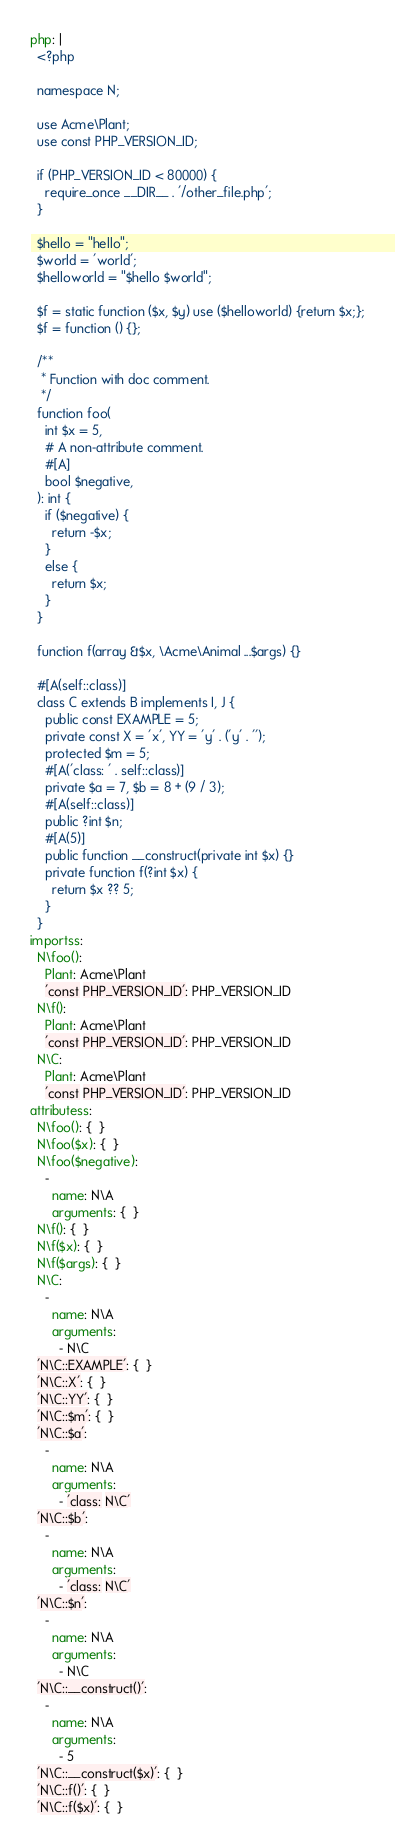Convert code to text. <code><loc_0><loc_0><loc_500><loc_500><_YAML_>php: |
  <?php

  namespace N;

  use Acme\Plant;
  use const PHP_VERSION_ID;

  if (PHP_VERSION_ID < 80000) {
    require_once __DIR__ . '/other_file.php';
  }

  $hello = "hello";
  $world = 'world';
  $helloworld = "$hello $world";

  $f = static function ($x, $y) use ($helloworld) {return $x;};
  $f = function () {};

  /**
   * Function with doc comment.
   */
  function foo(
    int $x = 5,
    # A non-attribute comment.
    #[A]
    bool $negative,
  ): int {
    if ($negative) {
      return -$x;
    }
    else {
      return $x;
    }
  }

  function f(array &$x, \Acme\Animal ...$args) {}

  #[A(self::class)]
  class C extends B implements I, J {
    public const EXAMPLE = 5;
    private const X = 'x', YY = 'y' . ('y' . '');
    protected $m = 5;
    #[A('class: ' . self::class)]
    private $a = 7, $b = 8 + (9 / 3);
    #[A(self::class)]
    public ?int $n;
    #[A(5)]
    public function __construct(private int $x) {}
    private function f(?int $x) {
      return $x ?? 5;
    }
  }
importss:
  N\foo():
    Plant: Acme\Plant
    'const PHP_VERSION_ID': PHP_VERSION_ID
  N\f():
    Plant: Acme\Plant
    'const PHP_VERSION_ID': PHP_VERSION_ID
  N\C:
    Plant: Acme\Plant
    'const PHP_VERSION_ID': PHP_VERSION_ID
attributess:
  N\foo(): {  }
  N\foo($x): {  }
  N\foo($negative):
    -
      name: N\A
      arguments: {  }
  N\f(): {  }
  N\f($x): {  }
  N\f($args): {  }
  N\C:
    -
      name: N\A
      arguments:
        - N\C
  'N\C::EXAMPLE': {  }
  'N\C::X': {  }
  'N\C::YY': {  }
  'N\C::$m': {  }
  'N\C::$a':
    -
      name: N\A
      arguments:
        - 'class: N\C'
  'N\C::$b':
    -
      name: N\A
      arguments:
        - 'class: N\C'
  'N\C::$n':
    -
      name: N\A
      arguments:
        - N\C
  'N\C::__construct()':
    -
      name: N\A
      arguments:
        - 5
  'N\C::__construct($x)': {  }
  'N\C::f()': {  }
  'N\C::f($x)': {  }
</code> 